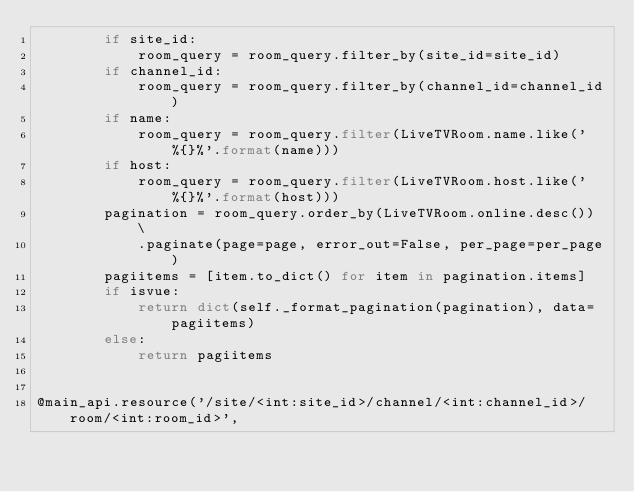<code> <loc_0><loc_0><loc_500><loc_500><_Python_>        if site_id:
            room_query = room_query.filter_by(site_id=site_id)
        if channel_id:
            room_query = room_query.filter_by(channel_id=channel_id)
        if name:
            room_query = room_query.filter(LiveTVRoom.name.like('%{}%'.format(name)))
        if host:
            room_query = room_query.filter(LiveTVRoom.host.like('%{}%'.format(host)))
        pagination = room_query.order_by(LiveTVRoom.online.desc()) \
            .paginate(page=page, error_out=False, per_page=per_page)
        pagiitems = [item.to_dict() for item in pagination.items]
        if isvue:
            return dict(self._format_pagination(pagination), data=pagiitems)
        else:
            return pagiitems


@main_api.resource('/site/<int:site_id>/channel/<int:channel_id>/room/<int:room_id>',</code> 